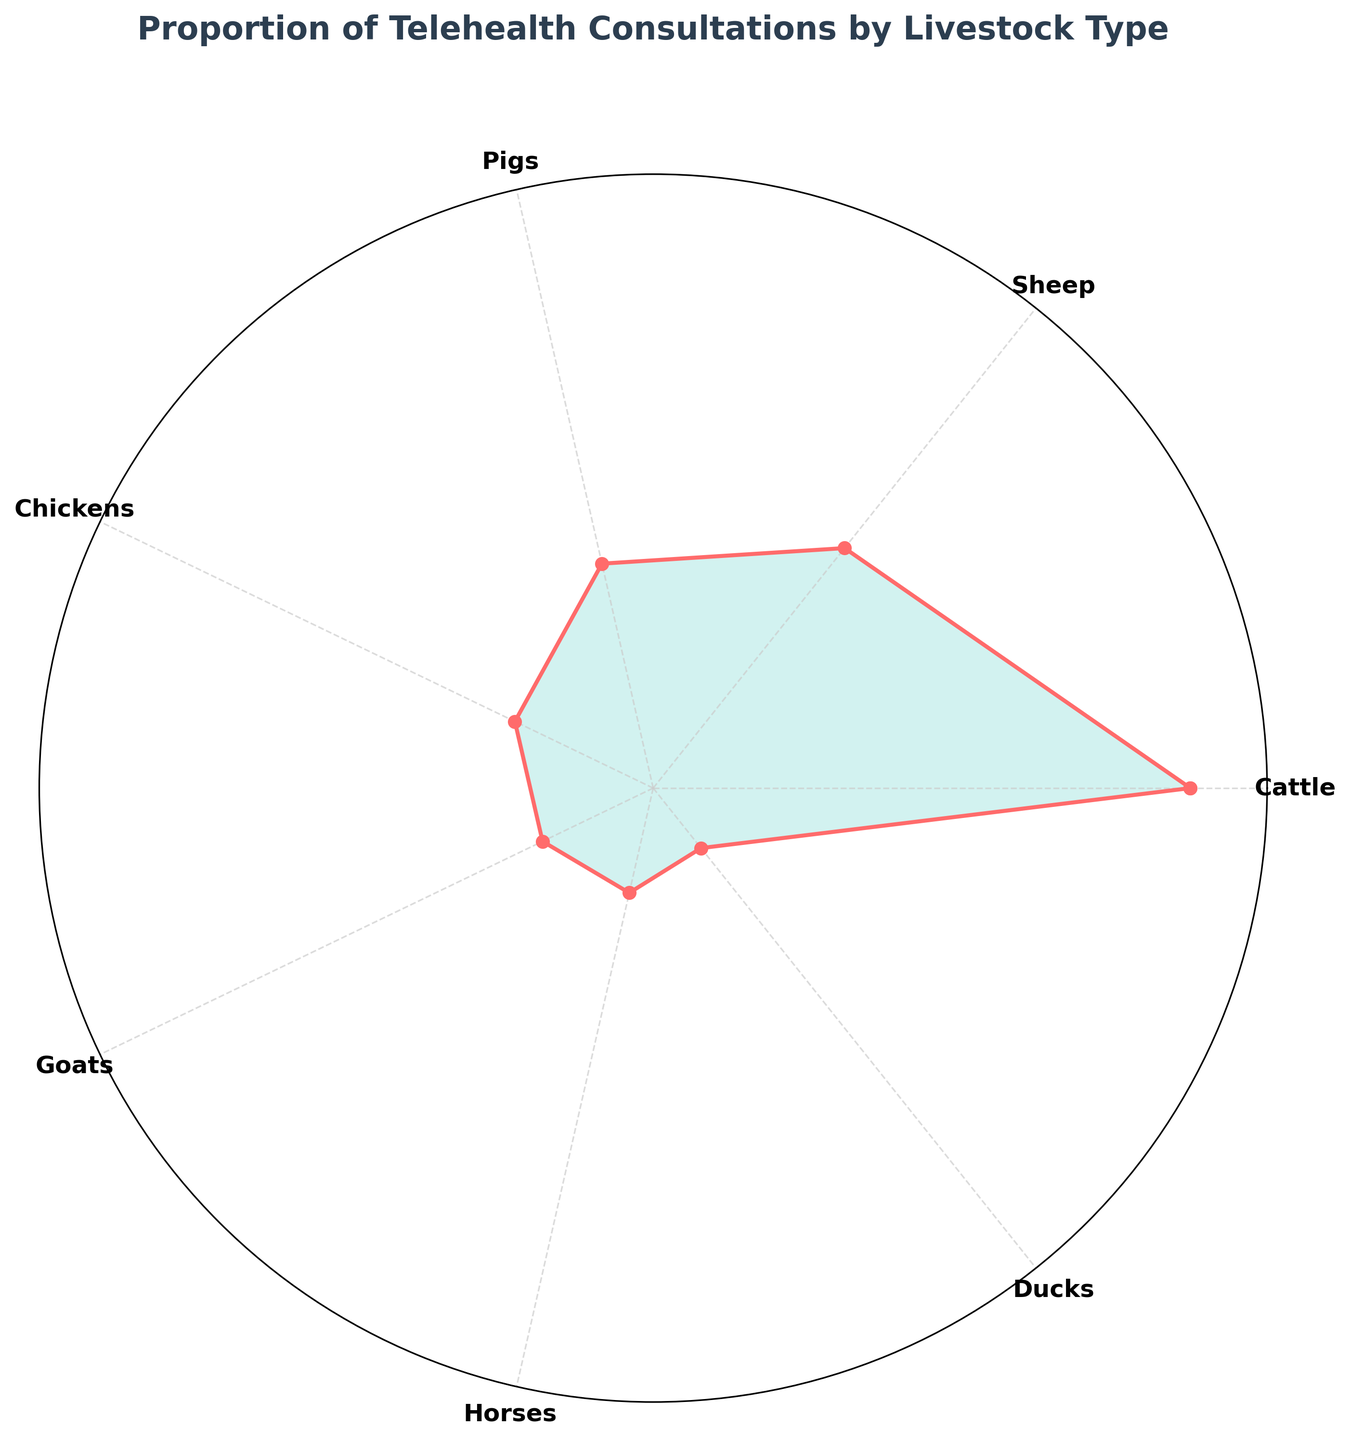What is the title of the chart? The title of the chart is usually displayed at the top of the figure. In this case, it reads "Proportion of Telehealth Consultations by Livestock Type."
Answer: Proportion of Telehealth Consultations by Livestock Type Which livestock type has the highest proportion of telehealth consultations? To find the livestock type with the highest proportion, refer to the slices and labels on the chart. The largest slice corresponds to the cattle, which shows 35%.
Answer: Cattle How many livestock types are shown in the chart? Count the number of unique segments labeled around the chart. There are seven distinct labels, each representing a different livestock type.
Answer: 7 What is the combined proportion of telehealth consultations for goats and horses? Find the proportion for goats (8%) and horses (7%). Sum these proportions: 8% + 7%.
Answer: 15% Is the proportion of telehealth consultations for chickens higher or lower than that for sheep? Compare the proportions of chickens (10%) and sheep (20%). Chickens have a lower proportion than sheep.
Answer: Lower What is the difference in the proportion of telehealth consultations between pigs and ducks? Subtract the proportion for ducks (5%) from the proportion for pigs (15%). The difference is 15% - 5%.
Answer: 10% Which two livestock types have proportions that sum up to 25%? Check pairs of livestock types and their associated proportions. Pigs (15%) and ducks (5%) together sum up to 20%, but sheep (20%) and ducks (5%) sum up to 25%.
Answer: Sheep and Ducks What is the average proportion of telehealth consultations across all livestock types? Sum all the proportions and divide by the number of livestock types: (35% + 20% + 15% + 10% + 8% + 7% + 5%) / 7. The calculation is 100% / 7.
Answer: ~14.29% Which livestock type has a proportion closest to the average proportion? Calculate the average proportion as ~14.29%. Compare it to each livestock type's proportion and note that pigs have a 15% proportion, which is closest to 14.29%.
Answer: Pigs If you were to merge the proportions of the three livestock types with the smallest proportions, what would their combined proportion be? Add the proportions of the three livestock types with the smallest proportions: ducks (5%), horses (7%), and goats (8%). The sum is 5% + 7% + 8%.
Answer: 20% 